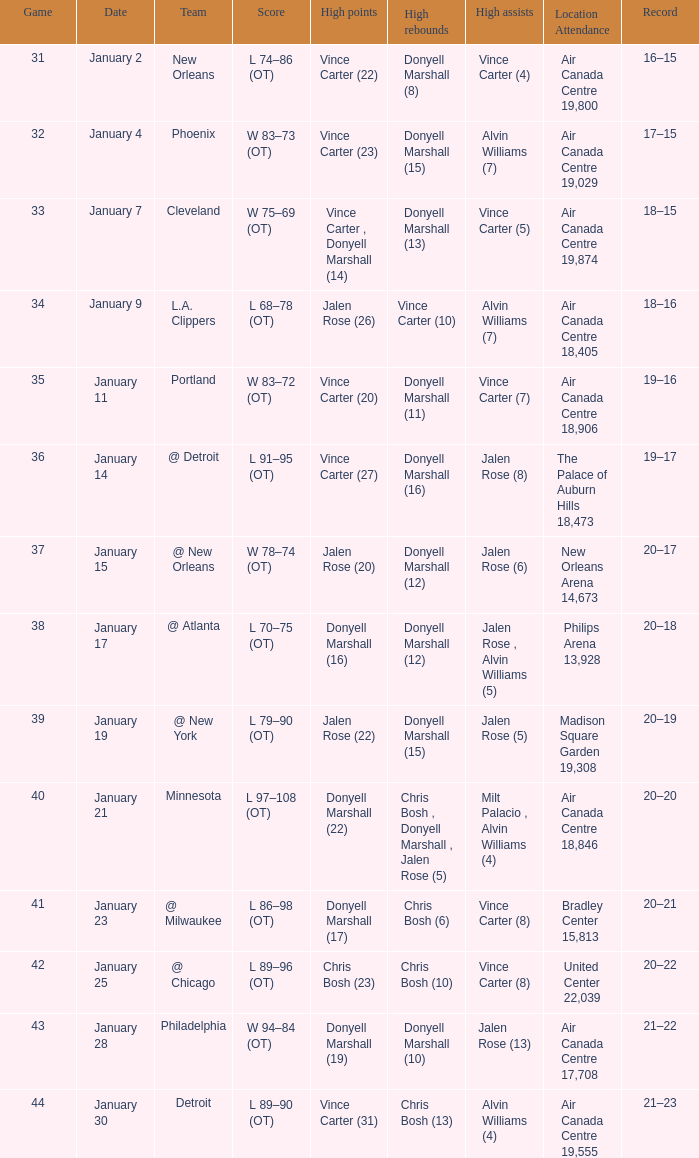What was the location and attendance for the game on january 2? Air Canada Centre 19,800. 